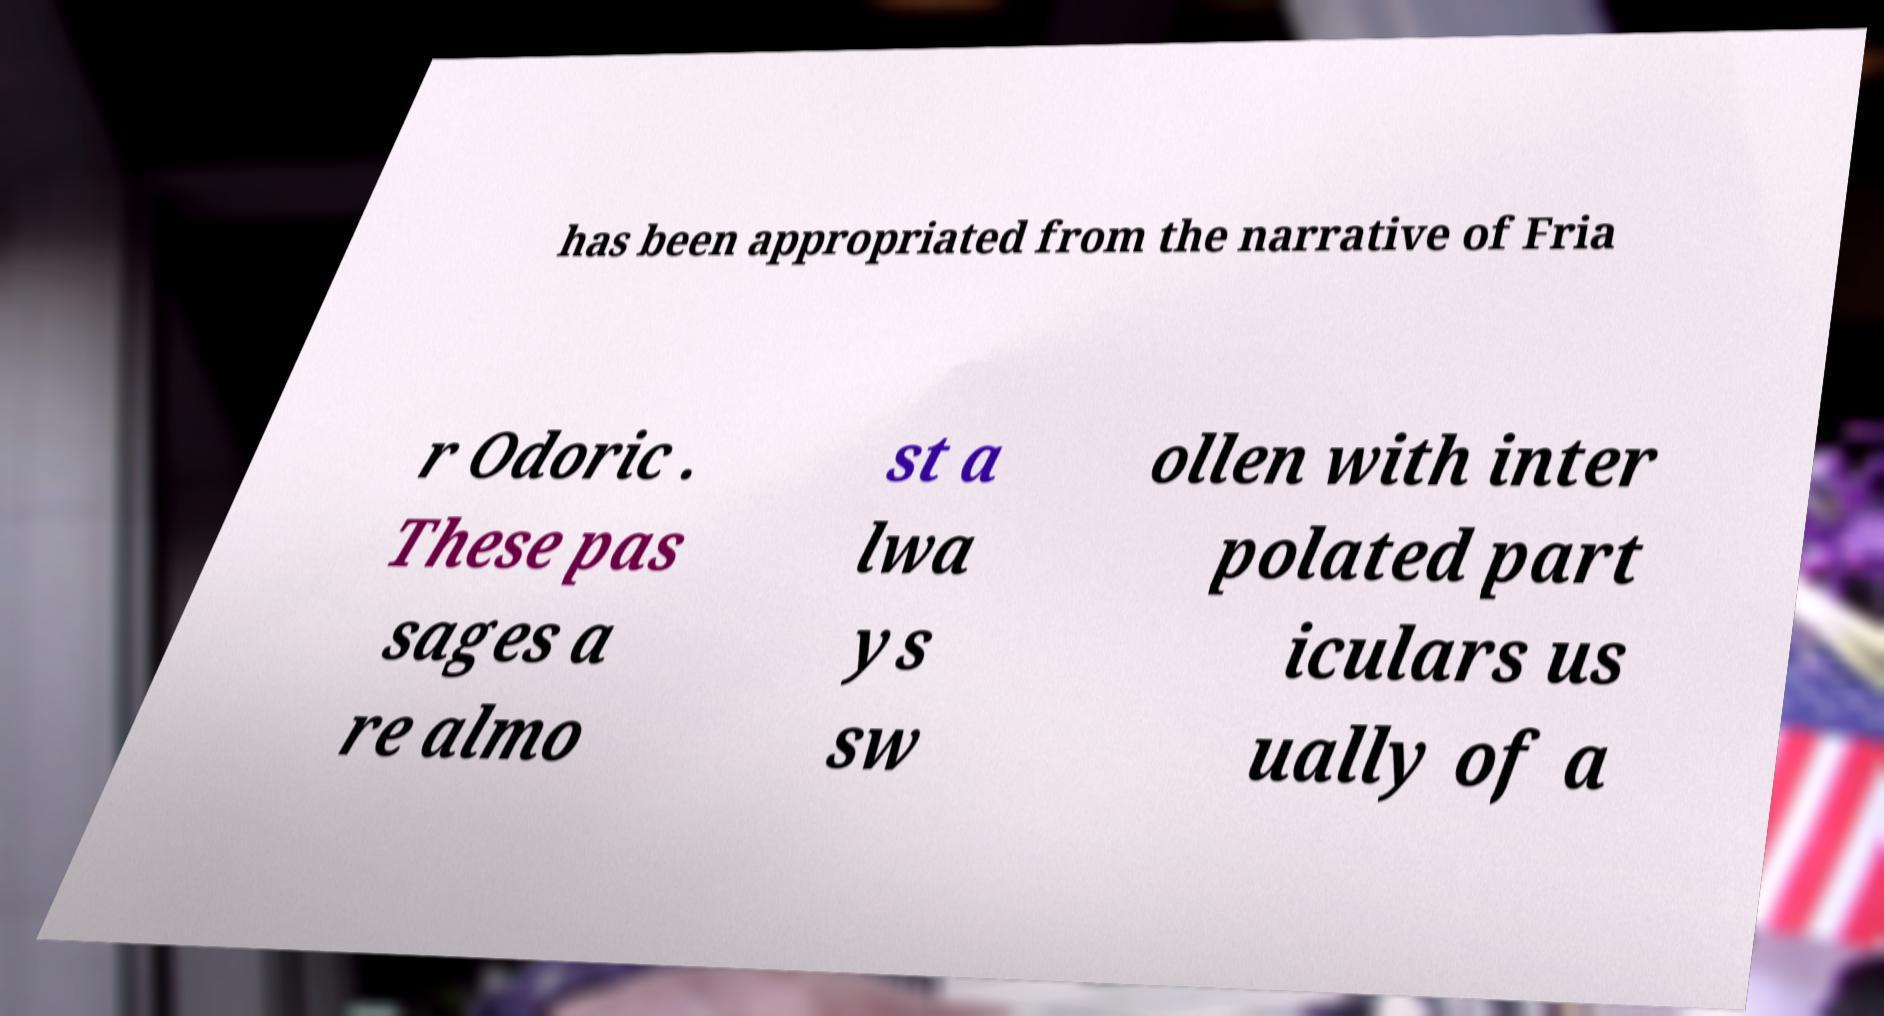There's text embedded in this image that I need extracted. Can you transcribe it verbatim? has been appropriated from the narrative of Fria r Odoric . These pas sages a re almo st a lwa ys sw ollen with inter polated part iculars us ually of a 